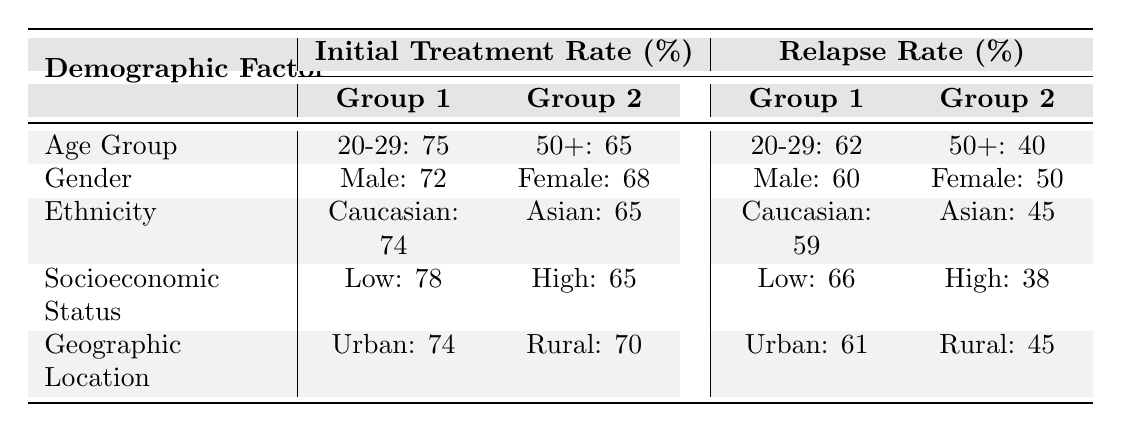What is the relapse rate for the 40-49 age group? According to the table, the relapse rate for the 40-49 age group is listed as 48%.
Answer: 48% Which demographic group has the highest initial treatment rate? Looking at the table, the "Low Income" group has the highest initial treatment rate at 78%.
Answer: 78% Is the relapse rate for females lower than that for males? The table shows that the relapse rate for females is 50%, while that for males is 60%. Therefore, it is true that females have a lower relapse rate than males.
Answer: Yes What is the difference in initial treatment rates between the "Low Income" and "High Income" groups? To find this difference, we subtract the initial treatment rate of the High Income group (65%) from that of the Low Income group (78%). So, 78 - 65 = 13%.
Answer: 13% What is the average relapse rate for all age groups listed? We find the relapse rates for each age group: 62% (20-29), 55% (30-39), 48% (40-49), and 40% (50+). Next, sum them: 62 + 55 + 48 + 40 = 205. Then, divide by the number of age groups (4): 205 / 4 = 51.25%.
Answer: 51.25% Which demographic factor has the greatest difference between initial treatment rate and relapse rate? We can compute the differences for each demographic factor: Age Group (20-29: 75-62=13; 50+: 65-40=25), Gender (72-60=12; 68-50=18), Ethnicity (74-59=15; 65-45=20), Socioeconomic Status (78-66=12; 65-38=27), Geographic Location (74-61=13; 70-45=25). The greatest difference is in the High Income group (27%).
Answer: High Income What is the relapse rate for the Hispanic demographic? According to the table, the relapse rate for the Hispanic demographic is 57%.
Answer: 57% For these demographic groups, which has the lowest initial treatment rate? The table shows the lowest initial treatment rate is for the "High Income" group at 65%.
Answer: 65% What is the median relapse rate for the demographic factors presented? The relapse rates are: 62%, 55%, 48%, 40%, 60%, 50%, 59%, 54%, 57%, 45%, 66%, 52%, 38%, 61%, and 45%. Arranging these values in order gives: 38%, 40%, 45%, 45%, 48%, 50%, 52%, 54%, 55%, 57%, 59%, 60%, 61%, 62%, and 66%. With 15 values, the median (8th in this case) is 54%.
Answer: 54% 